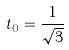<formula> <loc_0><loc_0><loc_500><loc_500>t _ { 0 } = \frac { 1 } { \sqrt { 3 } }</formula> 